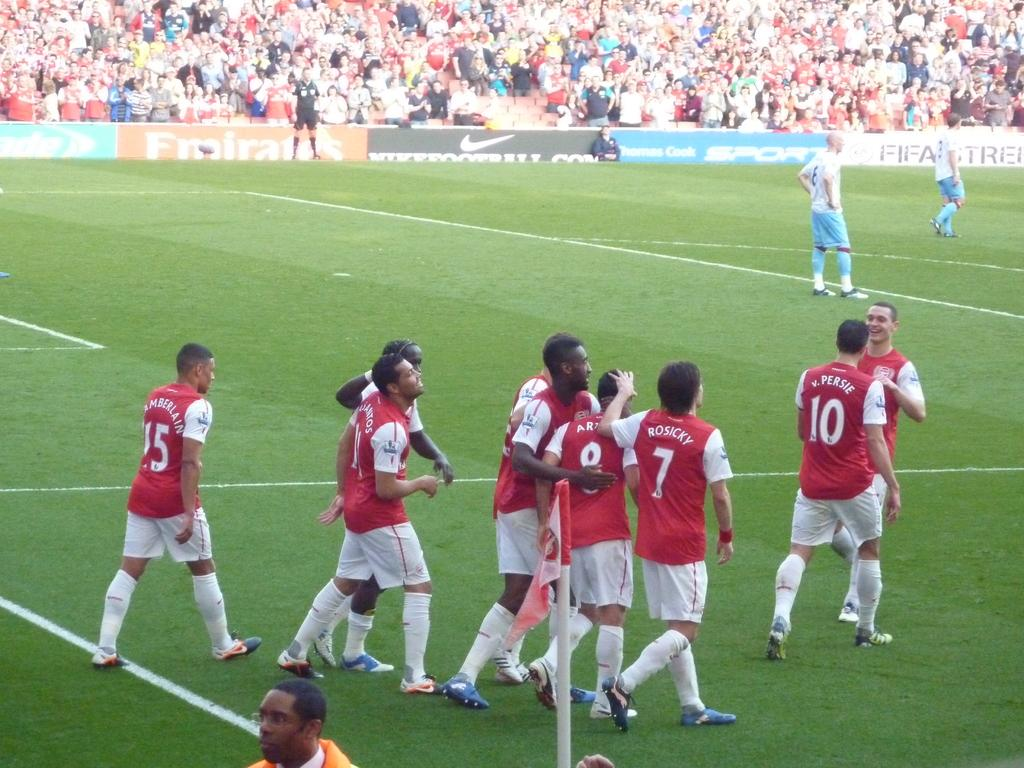Provide a one-sentence caption for the provided image. Persie and Rosicky walk on the field with a group of their red-shirted teammates. 